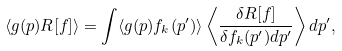Convert formula to latex. <formula><loc_0><loc_0><loc_500><loc_500>\langle g ( p ) R [ { f } ] \rangle = \int \langle g ( p ) f _ { k } ( p ^ { \prime } ) \rangle \left \langle \frac { \delta R [ { f } ] } { \delta f _ { k } ( p ^ { \prime } ) d p ^ { \prime } } \right \rangle d p ^ { \prime } ,</formula> 